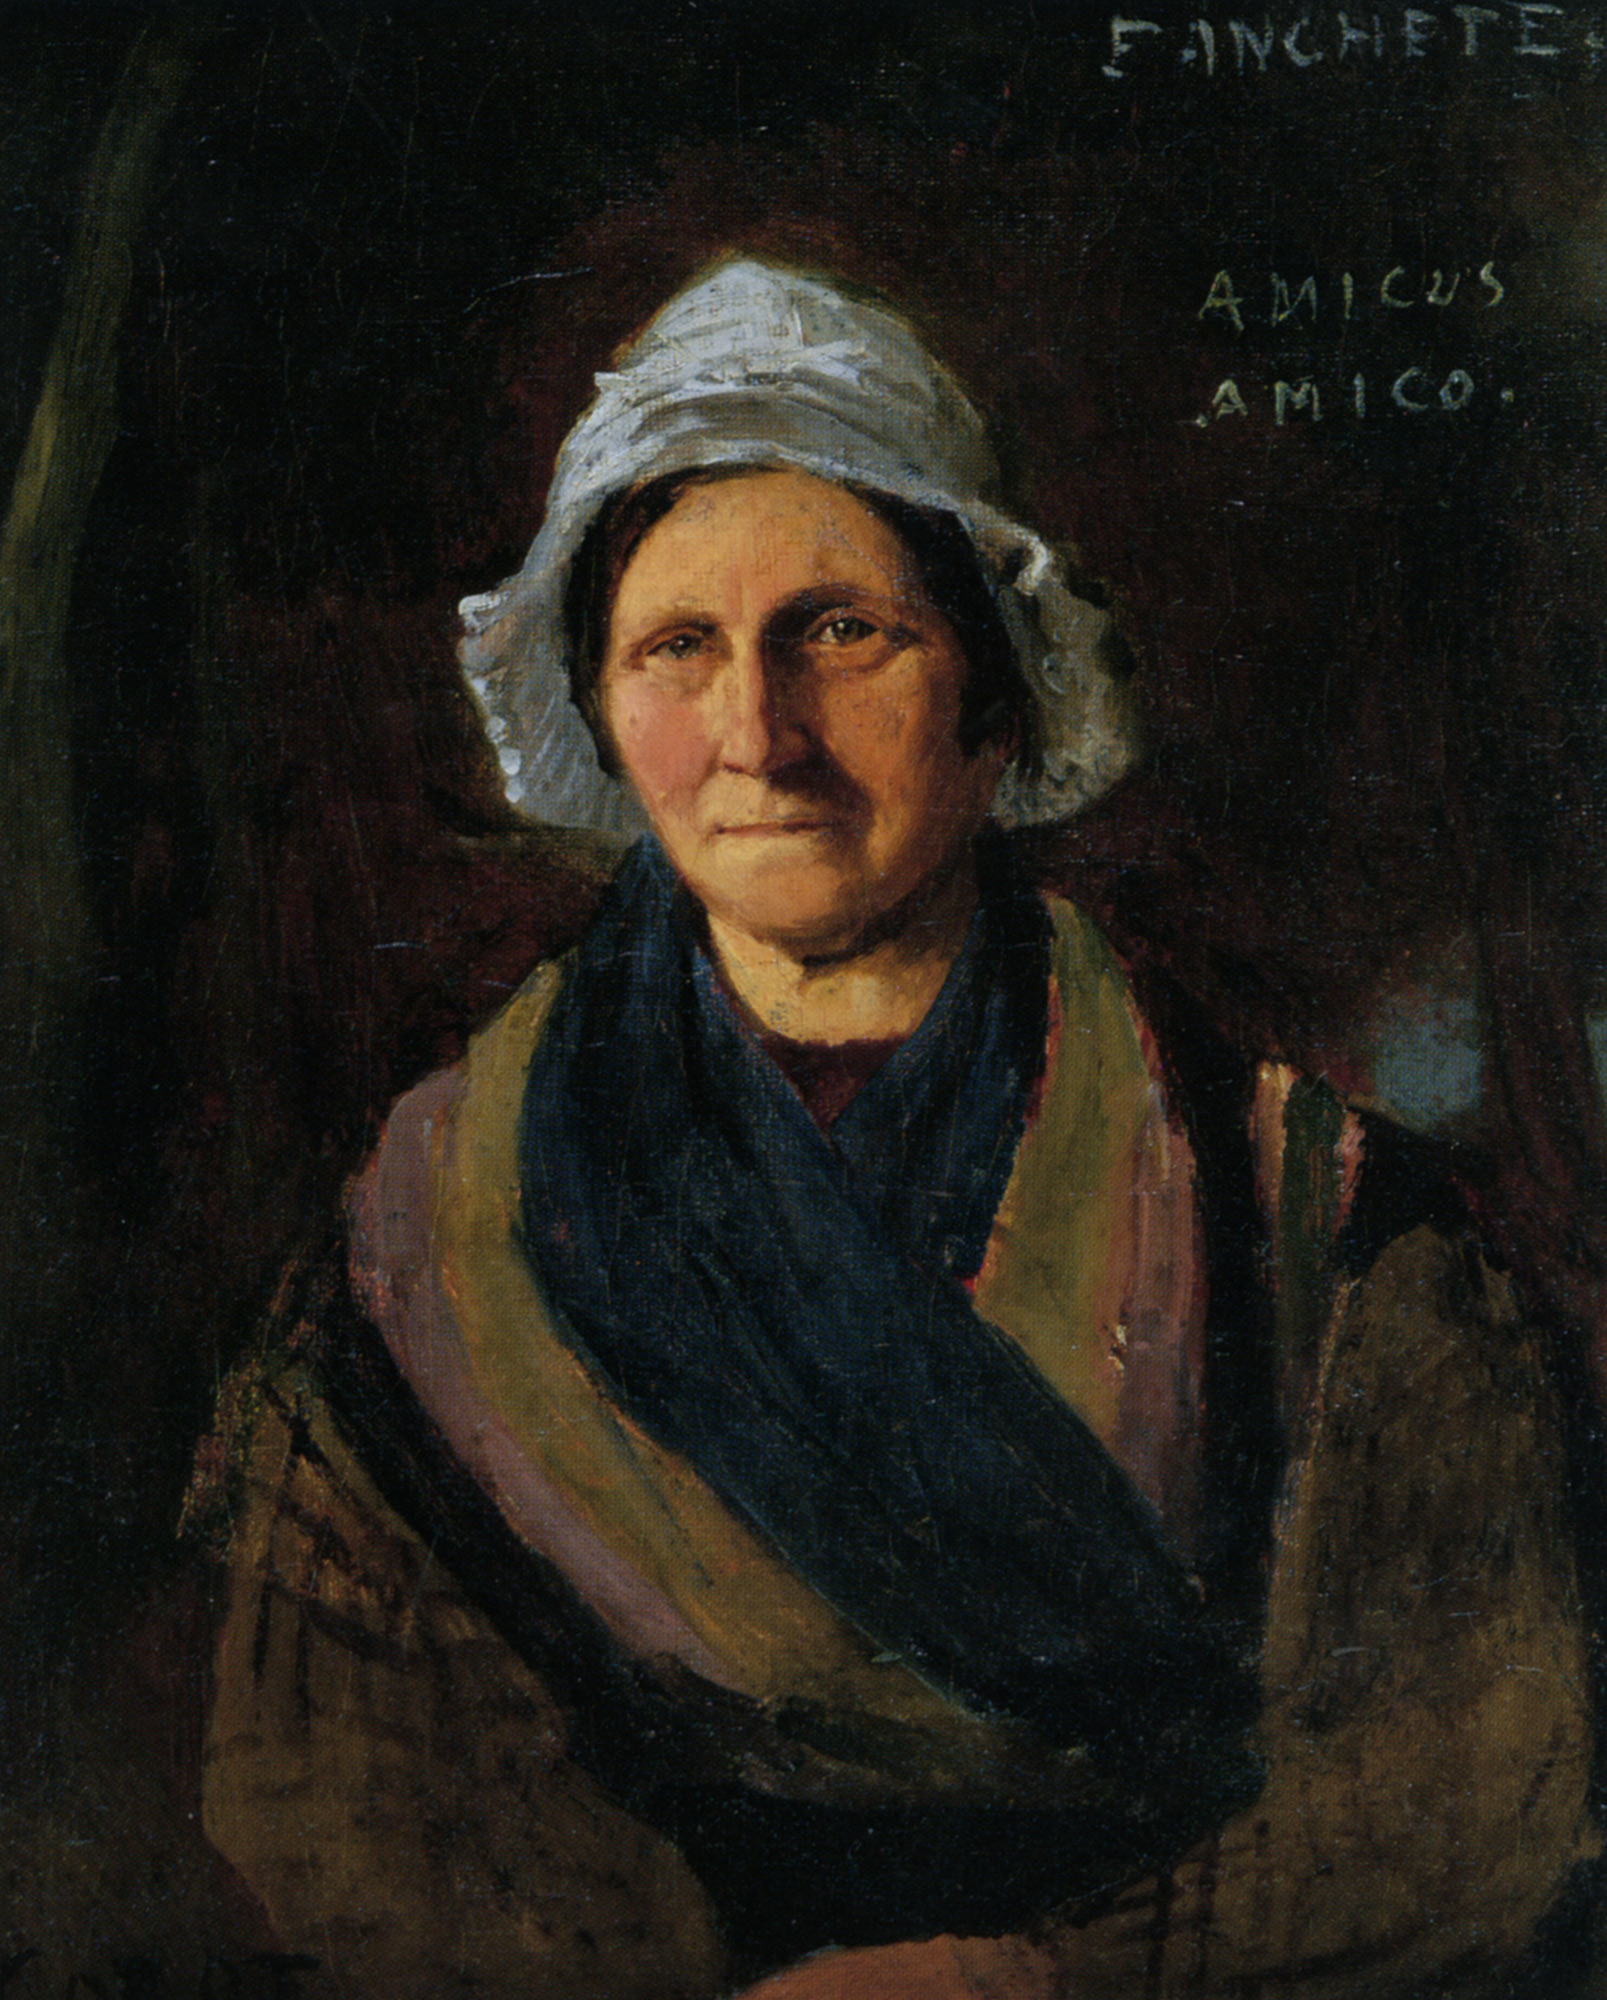Can you describe the artistic techniques used in the painting? The artist employed several notable techniques to create this painting. The use of chiaroscuro, the contrast between light and dark, is evident in how the woman's light-colored bonnet and shawl stand out against the dark background. This technique not only draws attention to the subject but also adds depth and a three-dimensional quality to the painting. The brushwork is meticulous, especially in rendering the textures of the woman's skin and clothing, indicating a high level of skill and precision. The artist likely used a fine brush for the details in her face and a broader brush for the background. The overall composition is balanced, with the woman centrally positioned, ensuring that she remains the focal point of the piece. 